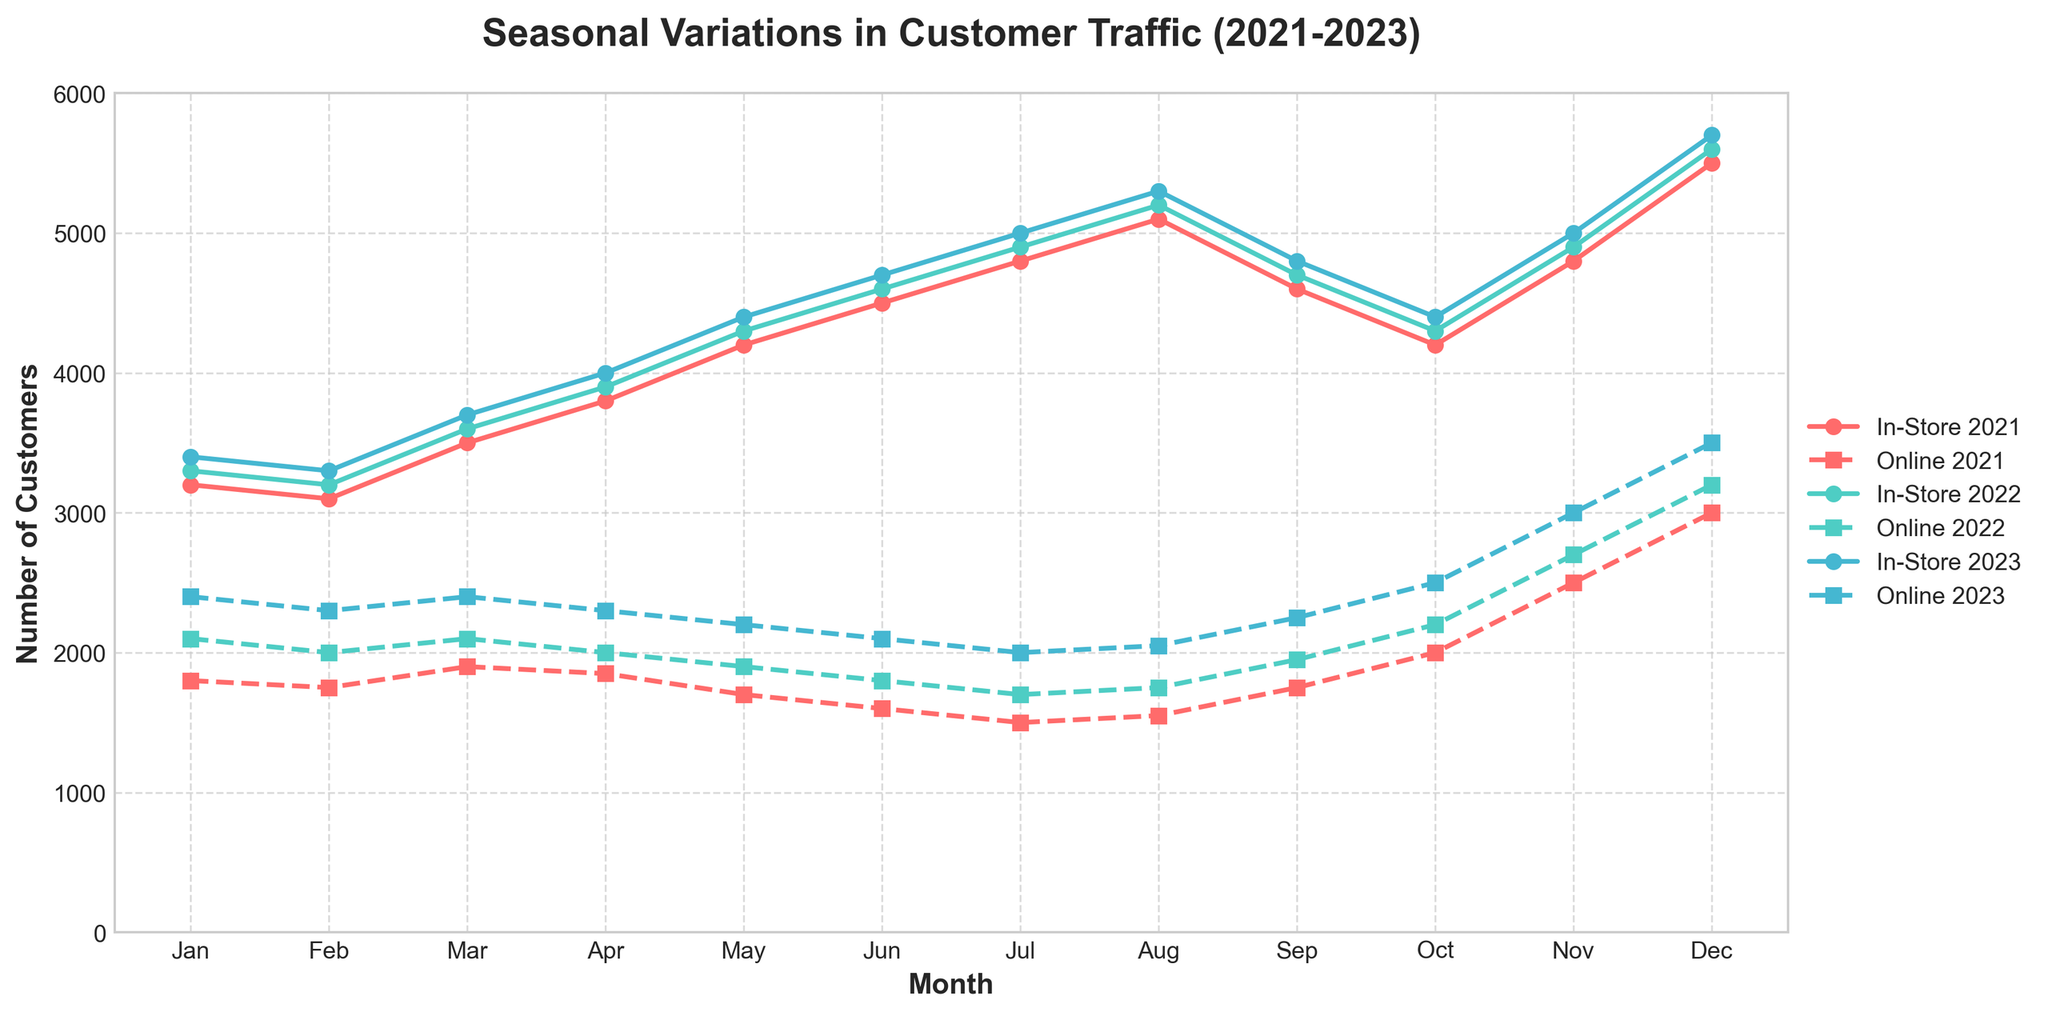What month had the highest in-store traffic in 2023? First, identify the peak point in the year 2023 for the in-store traffic line. The highest peak on the solid line for 2023 is in December.
Answer: December During which month did online orders see the most considerable drop from the previous month in any of the given years? Look for the online orders with the steepest decrease between two consecutive months. In June 2021, online orders dropped from 1700 in May 2021 to 1600, a significant drop of 100.
Answer: June 2021 What is the average in-store traffic for the month of November over the three years? Add the in-store traffic for November in 2021, 2022, and 2023, then divide by 3. (4800 + 4900 + 5000) / 3 = 15700 / 3 = 5233.33
Answer: 5233.33 How did online orders in April 2022 compare to those in April 2023? Compare the two values visually from the dashed lines of respective years. April 2022 recorded 2000, and April 2023 recorded 2300, showing an increase.
Answer: Increased Which year had the lowest overall in-store traffic in August? Compare the heights of the in-store solid line for August across the three years. The 2021 line (5100) is lower than the lines for 2022 (5200) and 2023 (5300).
Answer: 2021 By how much did online orders increase from July to December in 2023? First, note the online orders for July (2000) and December (3500) in 2023, and then calculate the difference: 3500 - 2000 = 1500.
Answer: 1500 Which year shows the least difference between peak in-store traffic and peak online orders? Compare the peak in-store and peak online values for each year: 2021 (5500 - 3000 = 2500), 2022 (5600 - 3200 = 2400), 2023 (5700 - 3500 = 2200). The least difference is in 2023.
Answer: 2023 Does the in-store traffic display a consistent pattern across the three years? Look for repeated trends in the solid lines over the years. All three years show a general increase towards December with a drop after January.
Answer: Yes 